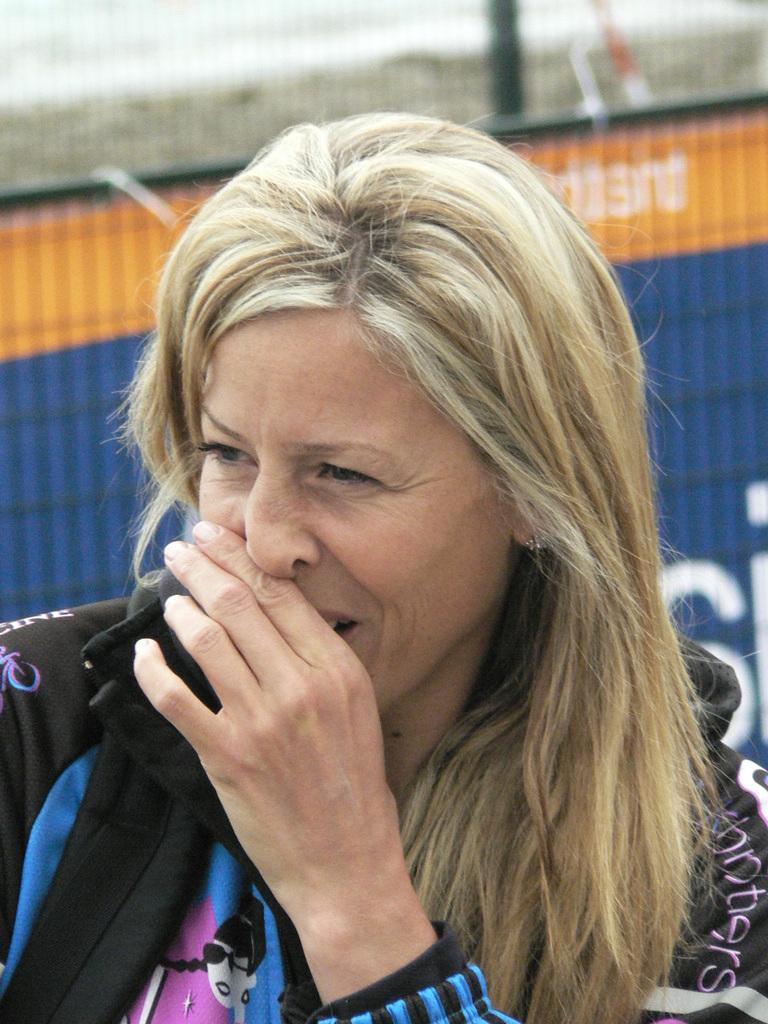Who is the main subject in the image? There is a woman in the image. Can you describe the background of the image? The background of the image is blurred. What type of creature is the doctor treating in the image? There is no doctor or creature present in the image; it only features a woman with a blurred background. 